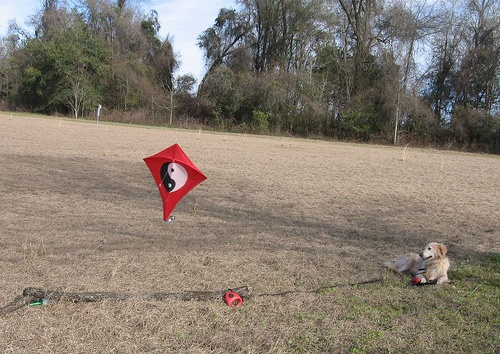Describe the objects in this image and their specific colors. I can see kite in lavender, brown, black, and pink tones and dog in lavender, gray, and darkgray tones in this image. 